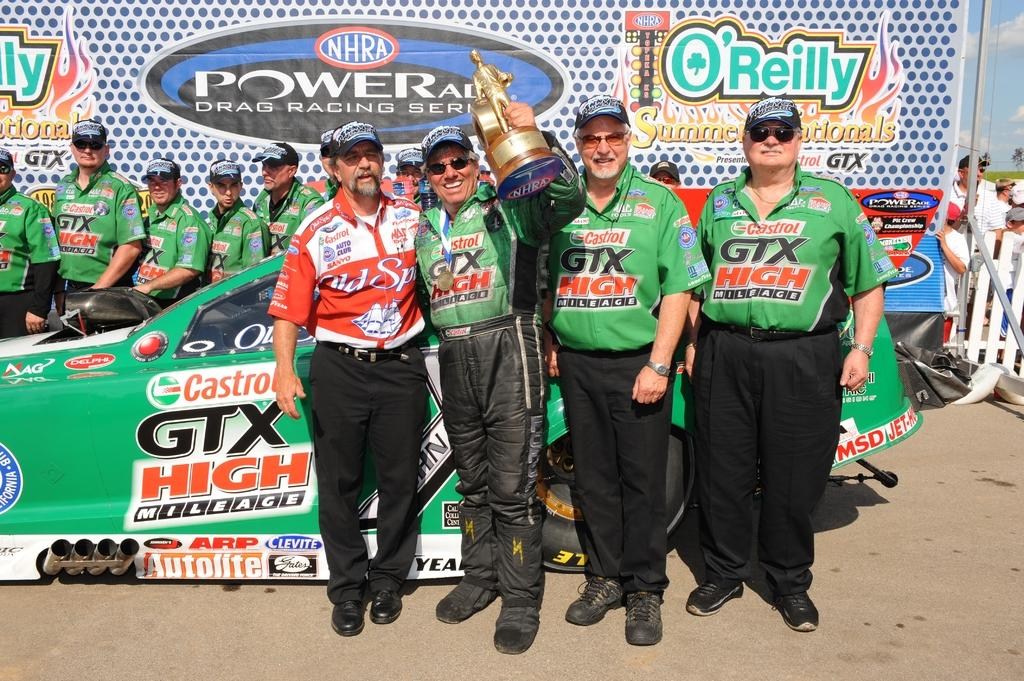<image>
Describe the image concisely. A team sponsored by Castrol GTX oil celebrates a victory at a motor racing event. 